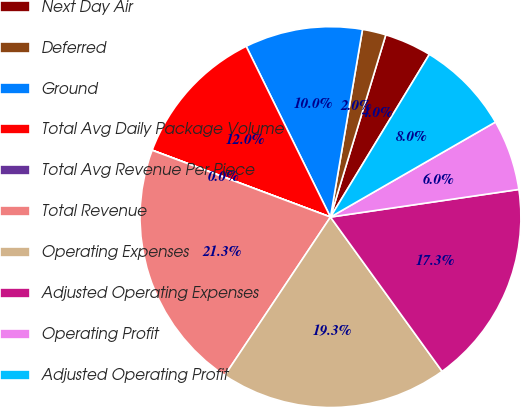Convert chart to OTSL. <chart><loc_0><loc_0><loc_500><loc_500><pie_chart><fcel>Next Day Air<fcel>Deferred<fcel>Ground<fcel>Total Avg Daily Package Volume<fcel>Total Avg Revenue Per Piece<fcel>Total Revenue<fcel>Operating Expenses<fcel>Adjusted Operating Expenses<fcel>Operating Profit<fcel>Adjusted Operating Profit<nl><fcel>4.0%<fcel>2.0%<fcel>9.99%<fcel>11.99%<fcel>0.01%<fcel>21.34%<fcel>19.34%<fcel>17.35%<fcel>6.0%<fcel>7.99%<nl></chart> 